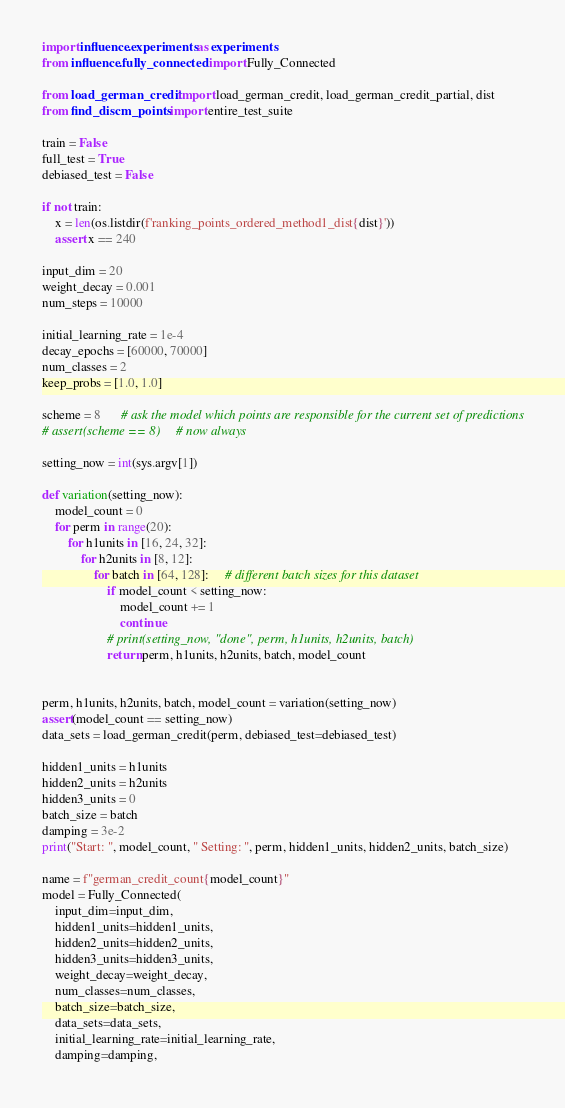Convert code to text. <code><loc_0><loc_0><loc_500><loc_500><_Python_>import influence.experiments as experiments
from influence.fully_connected import Fully_Connected

from load_german_credit import load_german_credit, load_german_credit_partial, dist
from find_discm_points import entire_test_suite

train = False
full_test = True
debiased_test = False

if not train:
    x = len(os.listdir(f'ranking_points_ordered_method1_dist{dist}'))
    assert x == 240

input_dim = 20
weight_decay = 0.001
num_steps = 10000

initial_learning_rate = 1e-4
decay_epochs = [60000, 70000]
num_classes = 2
keep_probs = [1.0, 1.0]

scheme = 8      # ask the model which points are responsible for the current set of predictions
# assert(scheme == 8)     # now always

setting_now = int(sys.argv[1])

def variation(setting_now):
    model_count = 0
    for perm in range(20):
        for h1units in [16, 24, 32]:
            for h2units in [8, 12]:
                for batch in [64, 128]:     # different batch sizes for this dataset
                    if model_count < setting_now:
                        model_count += 1
                        continue
                    # print(setting_now, "done", perm, h1units, h2units, batch)
                    return perm, h1units, h2units, batch, model_count


perm, h1units, h2units, batch, model_count = variation(setting_now)
assert(model_count == setting_now)
data_sets = load_german_credit(perm, debiased_test=debiased_test)

hidden1_units = h1units
hidden2_units = h2units
hidden3_units = 0
batch_size = batch
damping = 3e-2
print("Start: ", model_count, " Setting: ", perm, hidden1_units, hidden2_units, batch_size)

name = f"german_credit_count{model_count}"
model = Fully_Connected(
    input_dim=input_dim, 
    hidden1_units=hidden1_units, 
    hidden2_units=hidden2_units,
    hidden3_units=hidden3_units,
    weight_decay=weight_decay,
    num_classes=num_classes, 
    batch_size=batch_size,
    data_sets=data_sets,
    initial_learning_rate=initial_learning_rate,
    damping=damping,</code> 